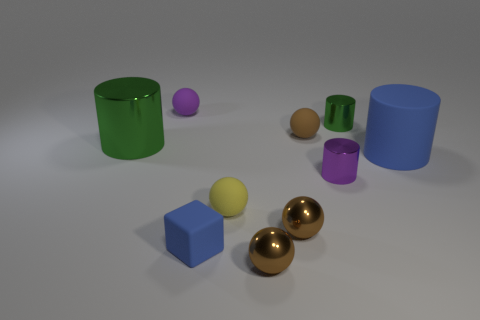Subtract all gray blocks. How many brown spheres are left? 3 Subtract 1 cylinders. How many cylinders are left? 3 Subtract all brown cylinders. Subtract all red spheres. How many cylinders are left? 4 Subtract all cylinders. How many objects are left? 6 Subtract all brown matte things. Subtract all small blue rubber spheres. How many objects are left? 9 Add 6 large green cylinders. How many large green cylinders are left? 7 Add 6 tiny purple metallic objects. How many tiny purple metallic objects exist? 7 Subtract 0 blue spheres. How many objects are left? 10 